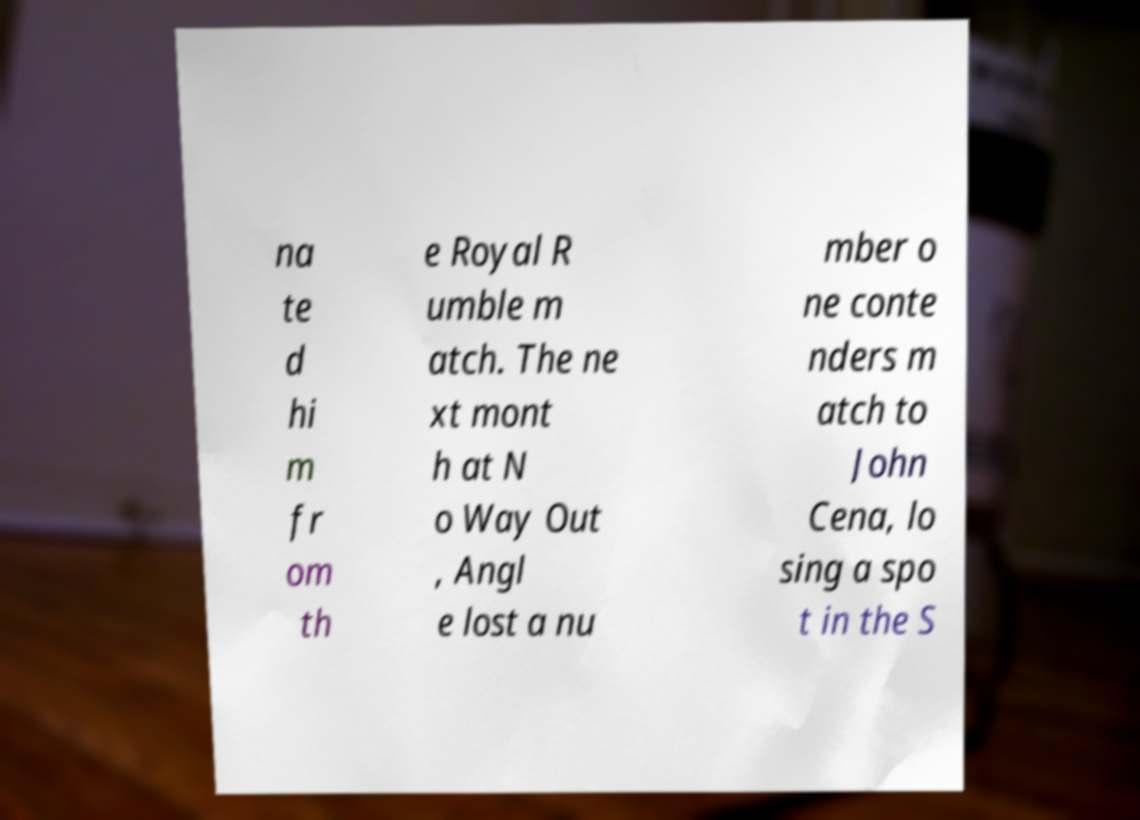There's text embedded in this image that I need extracted. Can you transcribe it verbatim? na te d hi m fr om th e Royal R umble m atch. The ne xt mont h at N o Way Out , Angl e lost a nu mber o ne conte nders m atch to John Cena, lo sing a spo t in the S 